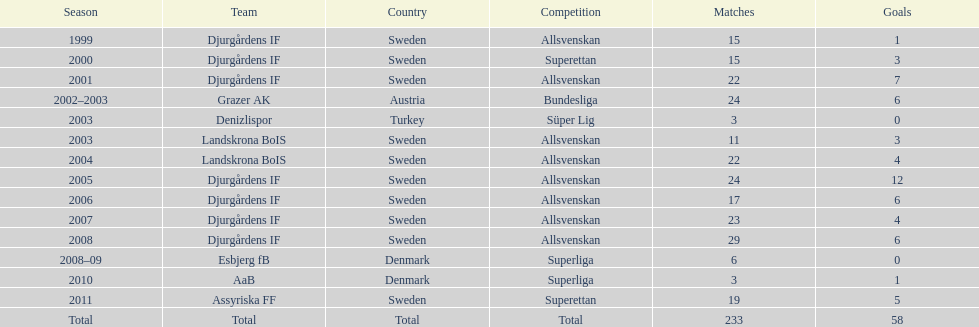How many games did jones kusi-asare participate in during his debut season? 15. 